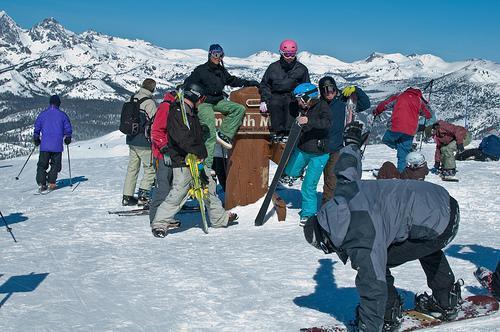How many people have pink helmets?
Give a very brief answer. 1. How many people are there?
Give a very brief answer. 10. How many zebras can you count?
Give a very brief answer. 0. 